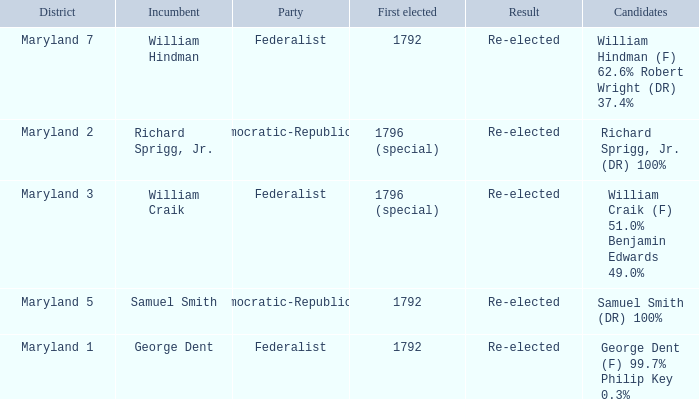What is the party when the incumbent is samuel smith? Democratic-Republican. 